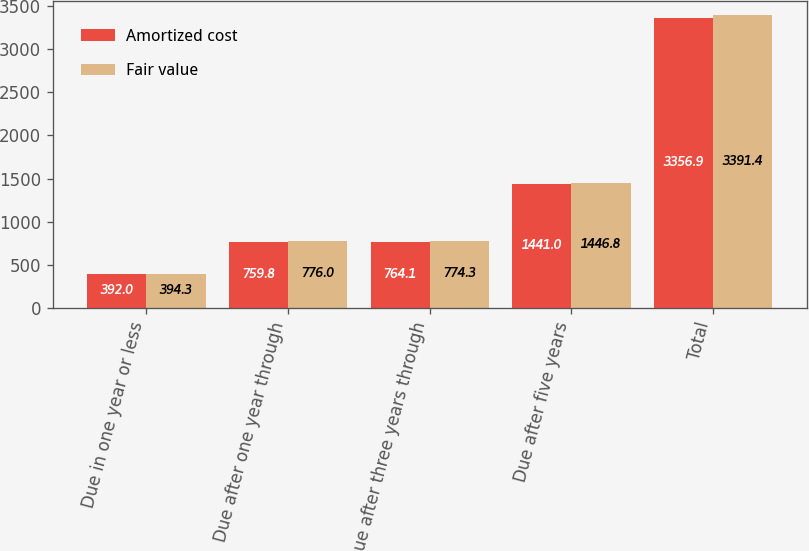Convert chart to OTSL. <chart><loc_0><loc_0><loc_500><loc_500><stacked_bar_chart><ecel><fcel>Due in one year or less<fcel>Due after one year through<fcel>Due after three years through<fcel>Due after five years<fcel>Total<nl><fcel>Amortized cost<fcel>392<fcel>759.8<fcel>764.1<fcel>1441<fcel>3356.9<nl><fcel>Fair value<fcel>394.3<fcel>776<fcel>774.3<fcel>1446.8<fcel>3391.4<nl></chart> 